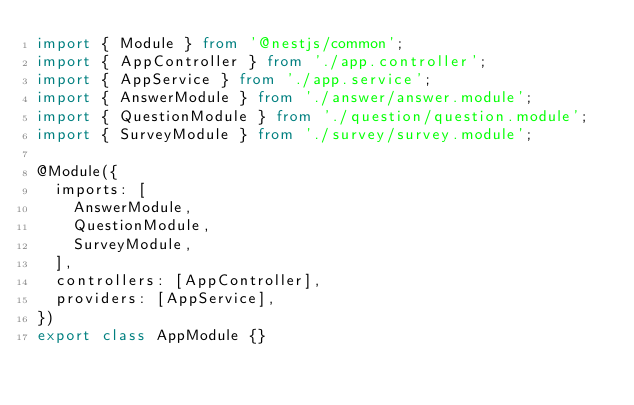Convert code to text. <code><loc_0><loc_0><loc_500><loc_500><_TypeScript_>import { Module } from '@nestjs/common';
import { AppController } from './app.controller';
import { AppService } from './app.service';
import { AnswerModule } from './answer/answer.module';
import { QuestionModule } from './question/question.module';
import { SurveyModule } from './survey/survey.module';

@Module({
  imports: [
    AnswerModule,
    QuestionModule,
    SurveyModule,
  ],
  controllers: [AppController],
  providers: [AppService],
})
export class AppModule {}
</code> 